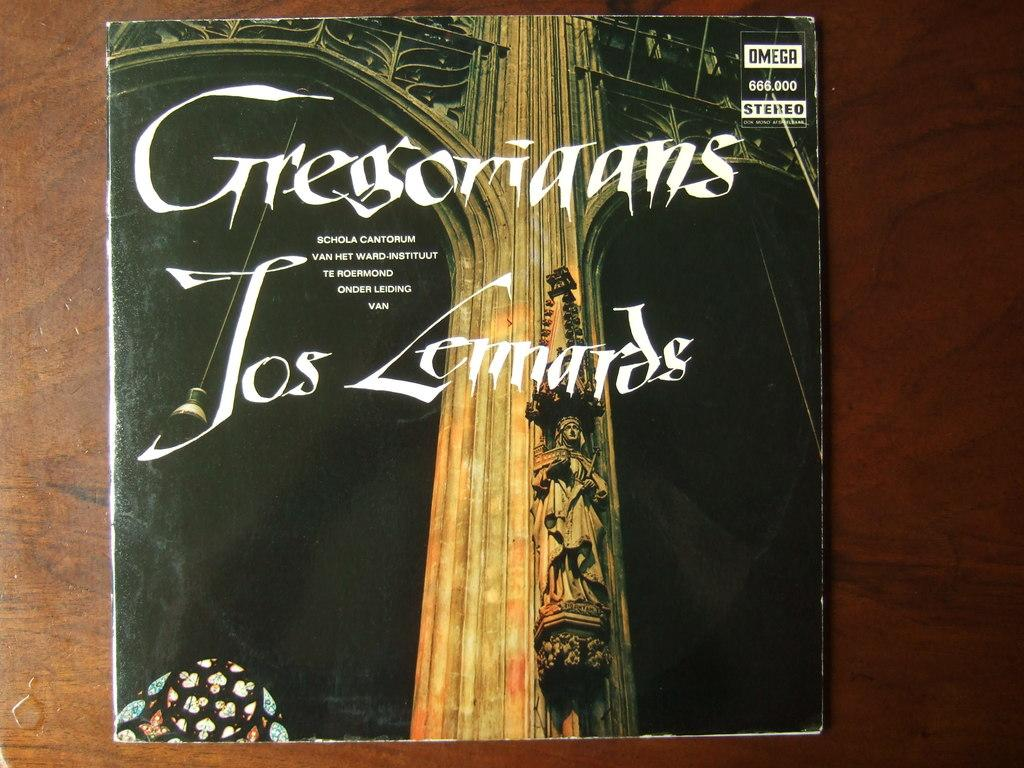<image>
Render a clear and concise summary of the photo. A book has the word omega in a white box in the upper right corner. 